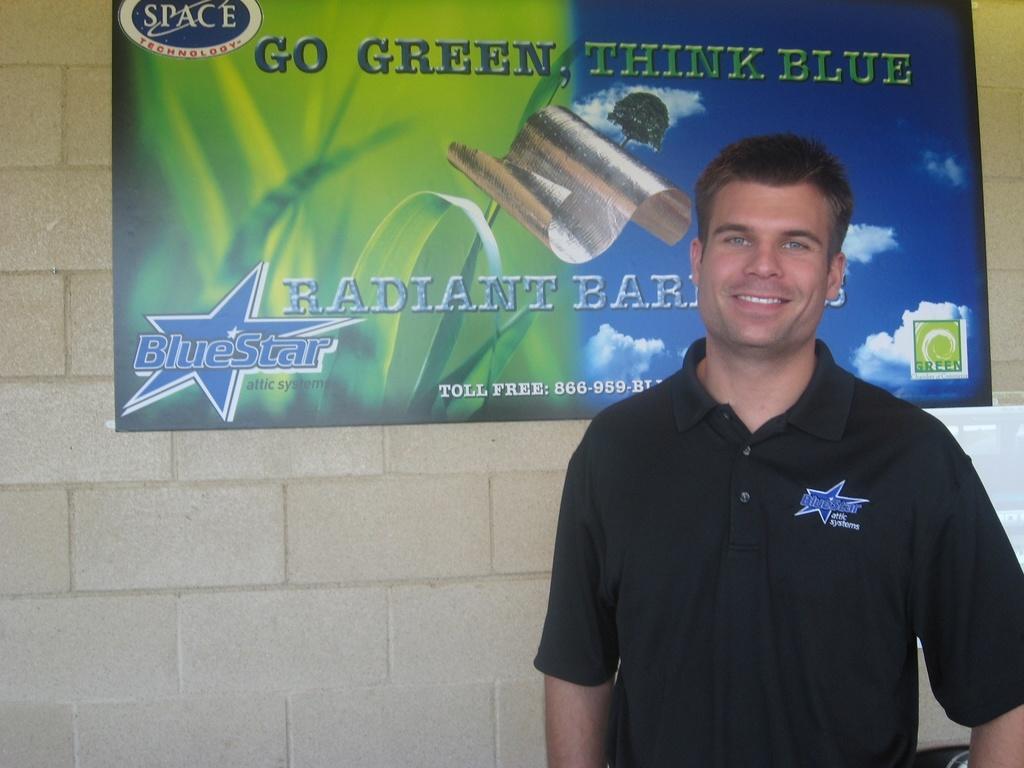How would you summarize this image in a sentence or two? In this picture we can see a person standing and smiling on the right side. We can see a poster on the wall. On this poster, we can see some text, star, silver object, clouds and a logo. 